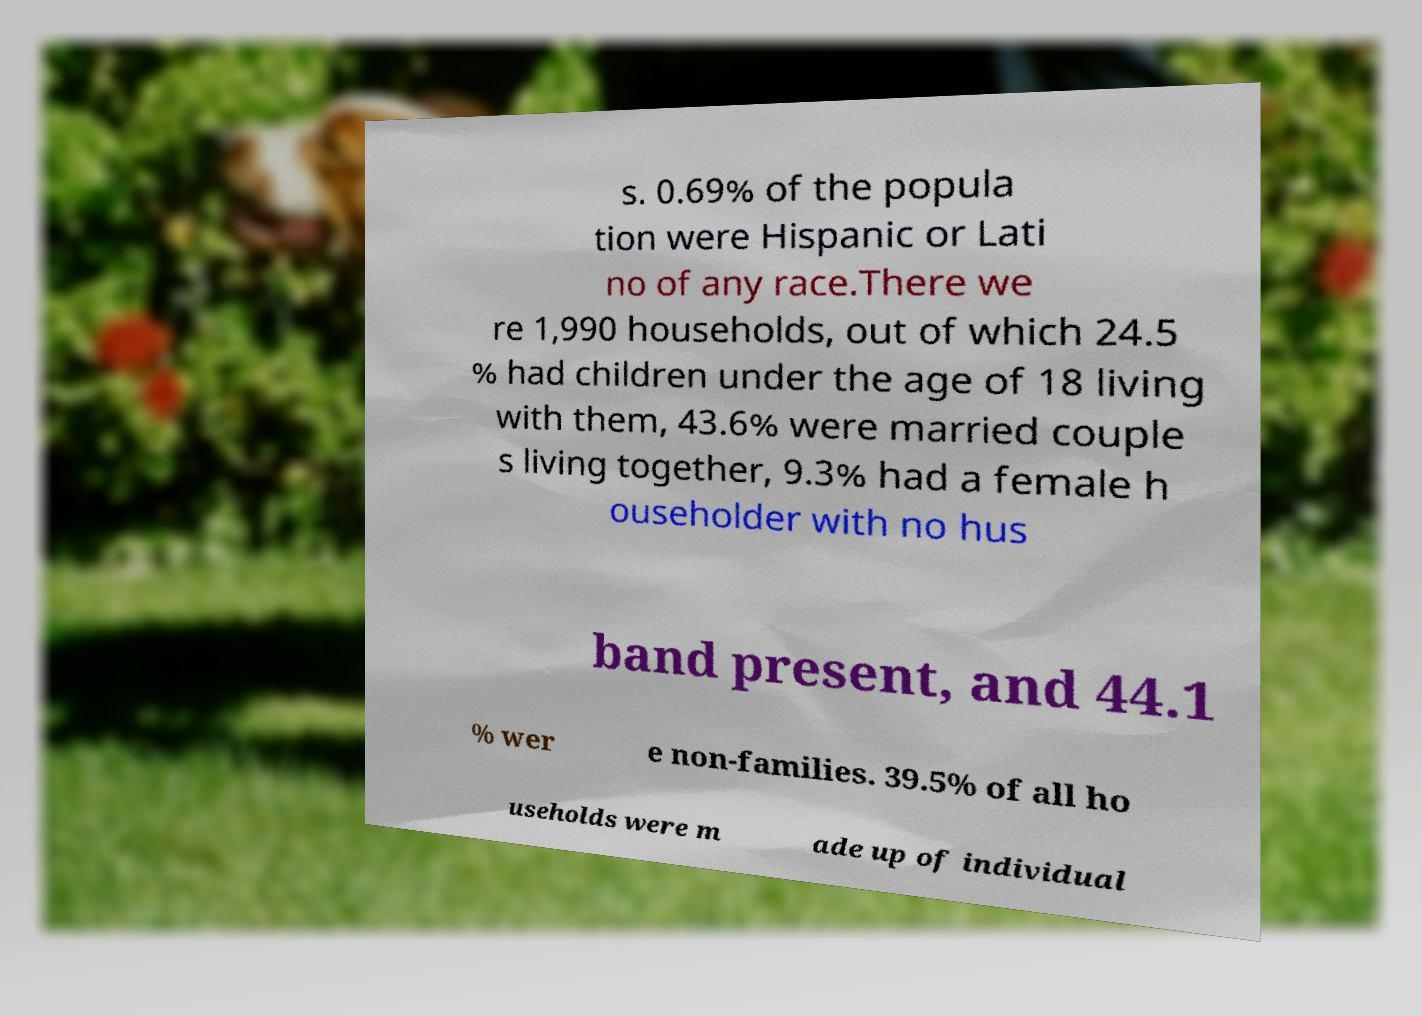Please read and relay the text visible in this image. What does it say? s. 0.69% of the popula tion were Hispanic or Lati no of any race.There we re 1,990 households, out of which 24.5 % had children under the age of 18 living with them, 43.6% were married couple s living together, 9.3% had a female h ouseholder with no hus band present, and 44.1 % wer e non-families. 39.5% of all ho useholds were m ade up of individual 